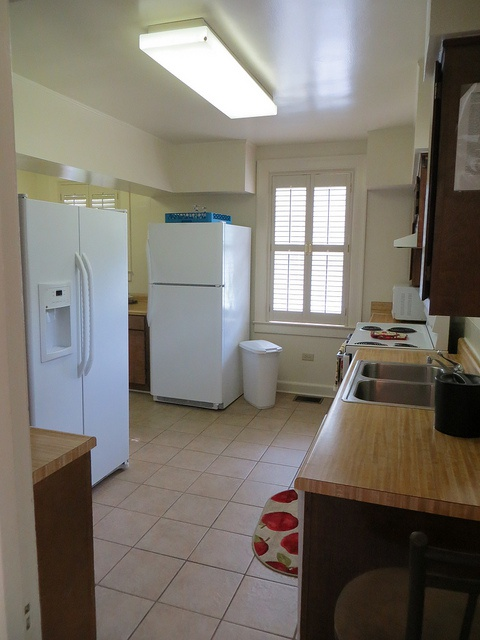Describe the objects in this image and their specific colors. I can see refrigerator in gray, darkgray, and lightblue tones, refrigerator in gray, lavender, and darkgray tones, chair in black and gray tones, sink in gray and black tones, and oven in gray, darkgray, and black tones in this image. 